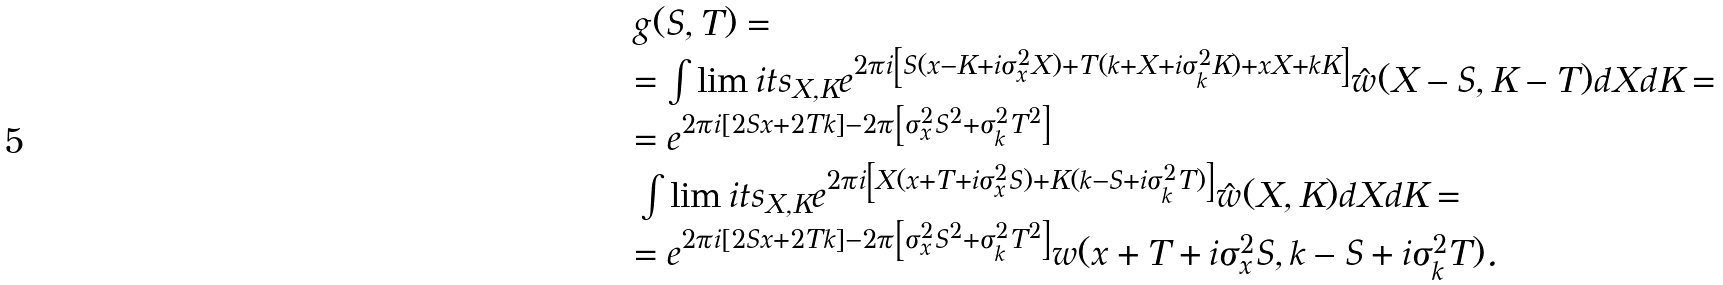<formula> <loc_0><loc_0><loc_500><loc_500>\begin{array} { l } g ( S , T ) = \\ = \int \lim i t s _ { X , K } { e ^ { 2 \pi i \left [ { S ( x - K + i \sigma _ { x } ^ { 2 } X ) + T ( k + X + i \sigma _ { k } ^ { 2 } K ) + x X + k K } \right ] } \hat { w } ( X - S , K - T ) d X d K } = \\ = e ^ { 2 \pi i \left [ { 2 S x + 2 T k } \right ] - 2 \pi \left [ { \sigma _ { x } ^ { 2 } S ^ { 2 } + \sigma _ { k } ^ { 2 } T ^ { 2 } } \right ] } \\ \, \int \lim i t s _ { X , K } { e ^ { 2 \pi i \left [ { X ( x + T + i \sigma _ { x } ^ { 2 } S ) + K ( k - S + i \sigma _ { k } ^ { 2 } T ) } \right ] } \hat { w } ( X , K ) d X d K } = \\ = e ^ { 2 \pi i \left [ { 2 S x + 2 T k } \right ] - 2 \pi \left [ { \sigma _ { x } ^ { 2 } S ^ { 2 } + \sigma _ { k } ^ { 2 } T ^ { 2 } } \right ] } w ( x + T + i \sigma _ { x } ^ { 2 } S , k - S + i \sigma _ { k } ^ { 2 } T ) . \end{array}</formula> 